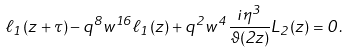Convert formula to latex. <formula><loc_0><loc_0><loc_500><loc_500>\ell _ { 1 } ( z + \tau ) - q ^ { 8 } w ^ { 1 6 } \ell _ { 1 } ( z ) + q ^ { 2 } w ^ { 4 } \frac { i \eta ^ { 3 } } { \vartheta ( 2 z ) } L _ { 2 } ( z ) = 0 .</formula> 